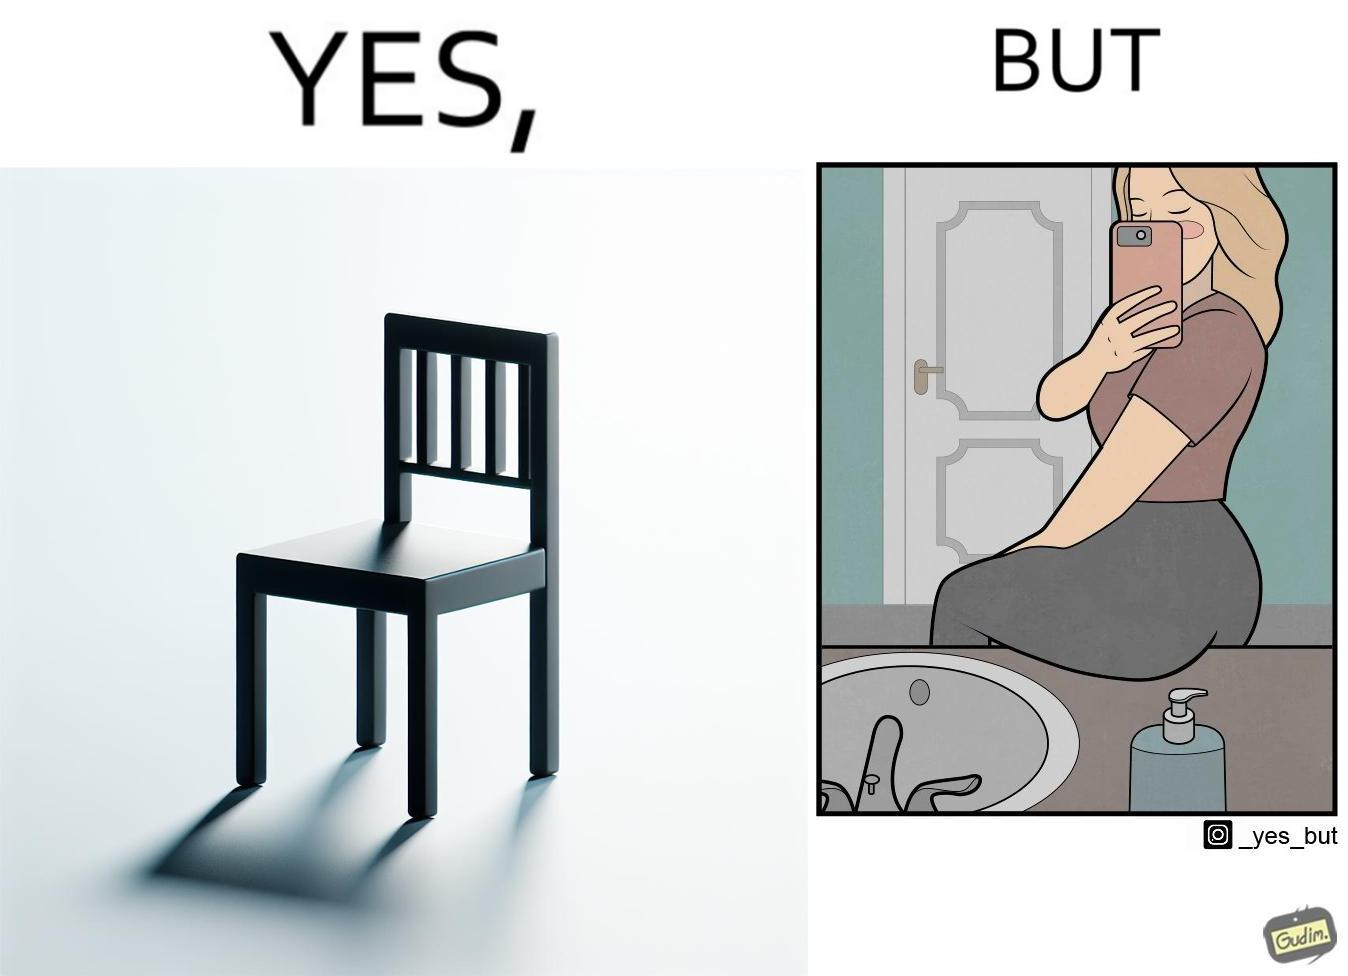Provide a description of this image. The image is ironical, as a woman is sitting by the sink taking a selfie using a mirror, while not using a chair that is actually meant for sitting. 